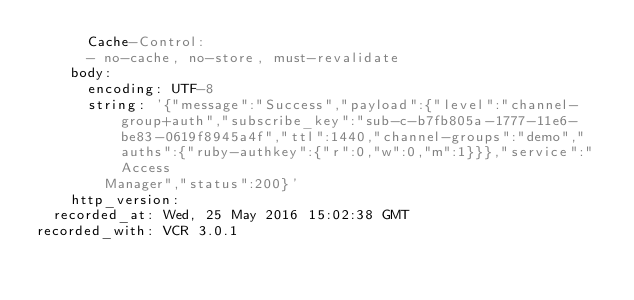<code> <loc_0><loc_0><loc_500><loc_500><_YAML_>      Cache-Control:
      - no-cache, no-store, must-revalidate
    body:
      encoding: UTF-8
      string: '{"message":"Success","payload":{"level":"channel-group+auth","subscribe_key":"sub-c-b7fb805a-1777-11e6-be83-0619f8945a4f","ttl":1440,"channel-groups":"demo","auths":{"ruby-authkey":{"r":0,"w":0,"m":1}}},"service":"Access
        Manager","status":200}'
    http_version: 
  recorded_at: Wed, 25 May 2016 15:02:38 GMT
recorded_with: VCR 3.0.1
</code> 